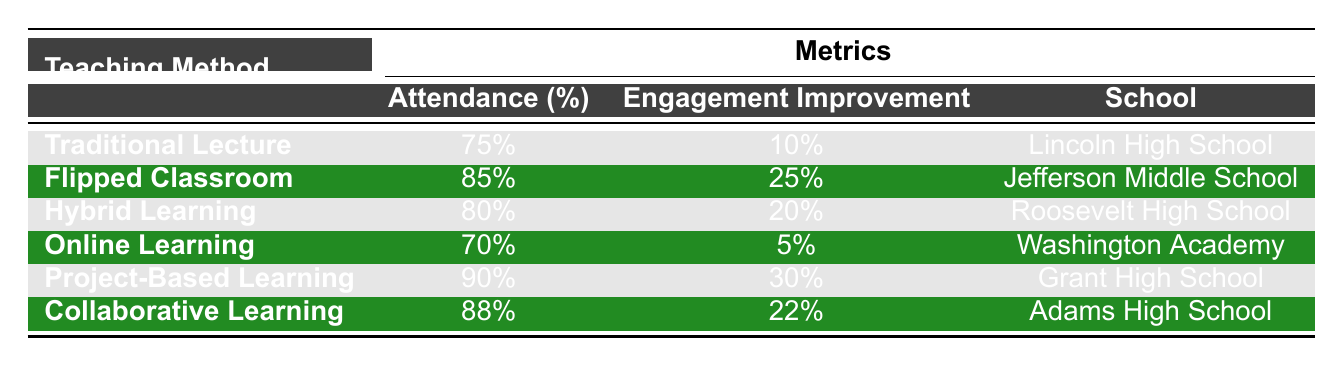What is the attendance percentage for Project-Based Learning? According to the table, the attendance percentage listed for Project-Based Learning is 90%.
Answer: 90% What school uses the Flipped Classroom method? From the table, the school that uses the Flipped Classroom method is Jefferson Middle School.
Answer: Jefferson Middle School Is the attendance percentage for Online Learning higher than that for Traditional Lecture? The attendance percentage for Online Learning is 70%, while for Traditional Lecture it is 75%. Since 70% is less than 75%, the statement is false.
Answer: No What is the engagement improvement percentage for Hybrid Learning? The table indicates that the engagement improvement percentage for Hybrid Learning is 20%.
Answer: 20% Which teaching method has the highest engagement improvement, and what is that percentage? By examining the table, Project-Based Learning has the highest engagement improvement at 30%.
Answer: 30% What is the average attendance percentage across all teaching methods listed in the table? The attendance percentages are 75, 85, 80, 70, 90, and 88. To find the average, we sum them (75 + 85 + 80 + 70 + 90 + 88 = 488) and divide by the number of teaching methods (6), resulting in an average of 81.33%.
Answer: 81.33% Which teaching methods have an attendance percentage above 80%? Looking at the table, the teaching methods with attendance percentages above 80% are Flipped Classroom (85%), Hybrid Learning (80% is not above), Project-Based Learning (90%), and Collaborative Learning (88%).
Answer: Flipped Classroom, Project-Based Learning, Collaborative Learning Is the attendance percentage for Collaborative Learning greater than the engagement improvement percentage? The attendance percentage for Collaborative Learning is 88%, and the engagement improvement is 22%. Since 88% is greater than 22%, the statement is true.
Answer: Yes Name the teaching method with the lowest attendance percentage and provide its value. The teaching method with the lowest attendance percentage in the table is Online Learning, with an attendance percentage of 70%.
Answer: Online Learning: 70% 